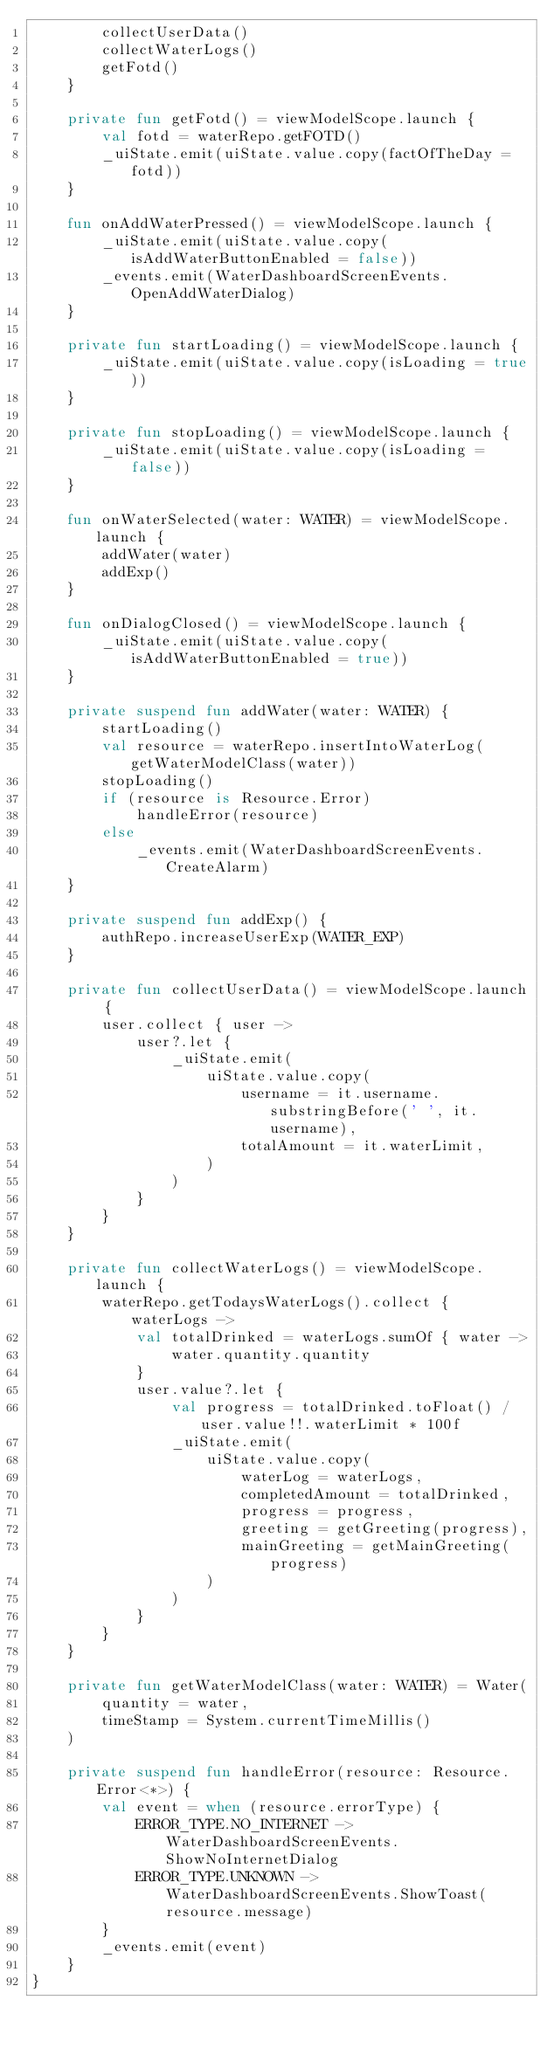<code> <loc_0><loc_0><loc_500><loc_500><_Kotlin_>        collectUserData()
        collectWaterLogs()
        getFotd()
    }

    private fun getFotd() = viewModelScope.launch {
        val fotd = waterRepo.getFOTD()
        _uiState.emit(uiState.value.copy(factOfTheDay = fotd))
    }

    fun onAddWaterPressed() = viewModelScope.launch {
        _uiState.emit(uiState.value.copy(isAddWaterButtonEnabled = false))
        _events.emit(WaterDashboardScreenEvents.OpenAddWaterDialog)
    }

    private fun startLoading() = viewModelScope.launch {
        _uiState.emit(uiState.value.copy(isLoading = true))
    }

    private fun stopLoading() = viewModelScope.launch {
        _uiState.emit(uiState.value.copy(isLoading = false))
    }

    fun onWaterSelected(water: WATER) = viewModelScope.launch {
        addWater(water)
        addExp()
    }

    fun onDialogClosed() = viewModelScope.launch {
        _uiState.emit(uiState.value.copy(isAddWaterButtonEnabled = true))
    }

    private suspend fun addWater(water: WATER) {
        startLoading()
        val resource = waterRepo.insertIntoWaterLog(getWaterModelClass(water))
        stopLoading()
        if (resource is Resource.Error)
            handleError(resource)
        else
            _events.emit(WaterDashboardScreenEvents.CreateAlarm)
    }

    private suspend fun addExp() {
        authRepo.increaseUserExp(WATER_EXP)
    }

    private fun collectUserData() = viewModelScope.launch {
        user.collect { user ->
            user?.let {
                _uiState.emit(
                    uiState.value.copy(
                        username = it.username.substringBefore(' ', it.username),
                        totalAmount = it.waterLimit,
                    )
                )
            }
        }
    }

    private fun collectWaterLogs() = viewModelScope.launch {
        waterRepo.getTodaysWaterLogs().collect { waterLogs ->
            val totalDrinked = waterLogs.sumOf { water ->
                water.quantity.quantity
            }
            user.value?.let {
                val progress = totalDrinked.toFloat() / user.value!!.waterLimit * 100f
                _uiState.emit(
                    uiState.value.copy(
                        waterLog = waterLogs,
                        completedAmount = totalDrinked,
                        progress = progress,
                        greeting = getGreeting(progress),
                        mainGreeting = getMainGreeting(progress)
                    )
                )
            }
        }
    }

    private fun getWaterModelClass(water: WATER) = Water(
        quantity = water,
        timeStamp = System.currentTimeMillis()
    )

    private suspend fun handleError(resource: Resource.Error<*>) {
        val event = when (resource.errorType) {
            ERROR_TYPE.NO_INTERNET -> WaterDashboardScreenEvents.ShowNoInternetDialog
            ERROR_TYPE.UNKNOWN -> WaterDashboardScreenEvents.ShowToast(resource.message)
        }
        _events.emit(event)
    }
}
</code> 